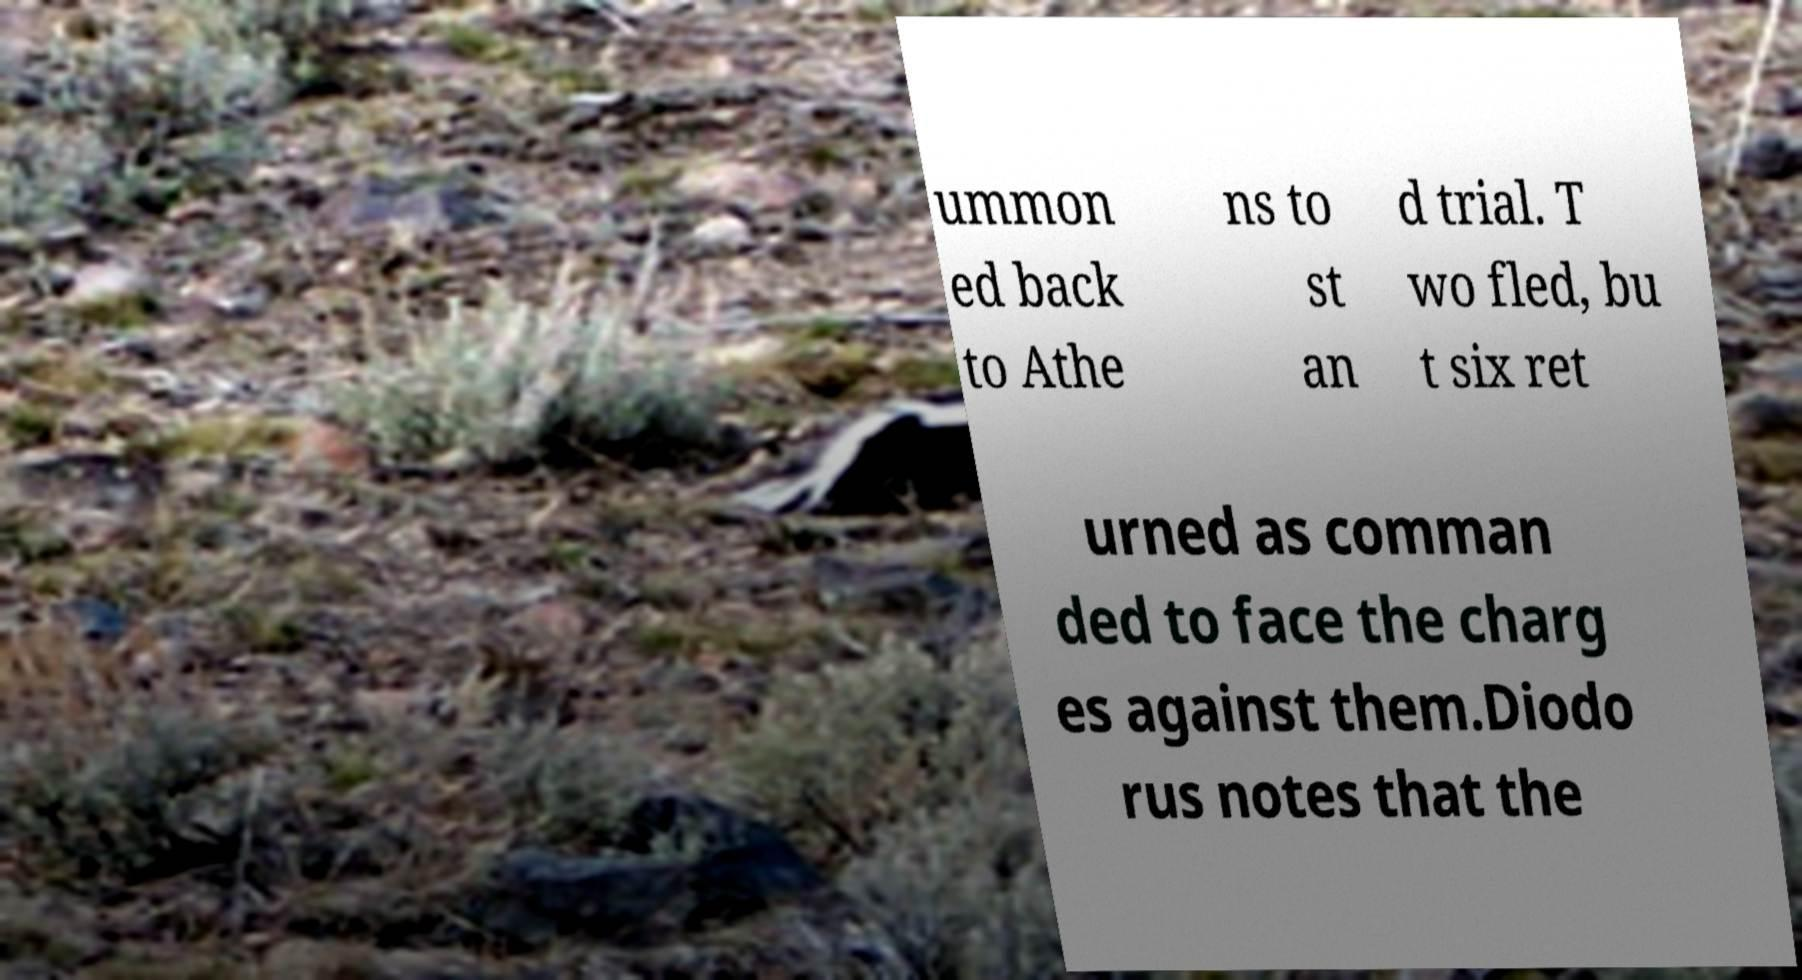What messages or text are displayed in this image? I need them in a readable, typed format. ummon ed back to Athe ns to st an d trial. T wo fled, bu t six ret urned as comman ded to face the charg es against them.Diodo rus notes that the 